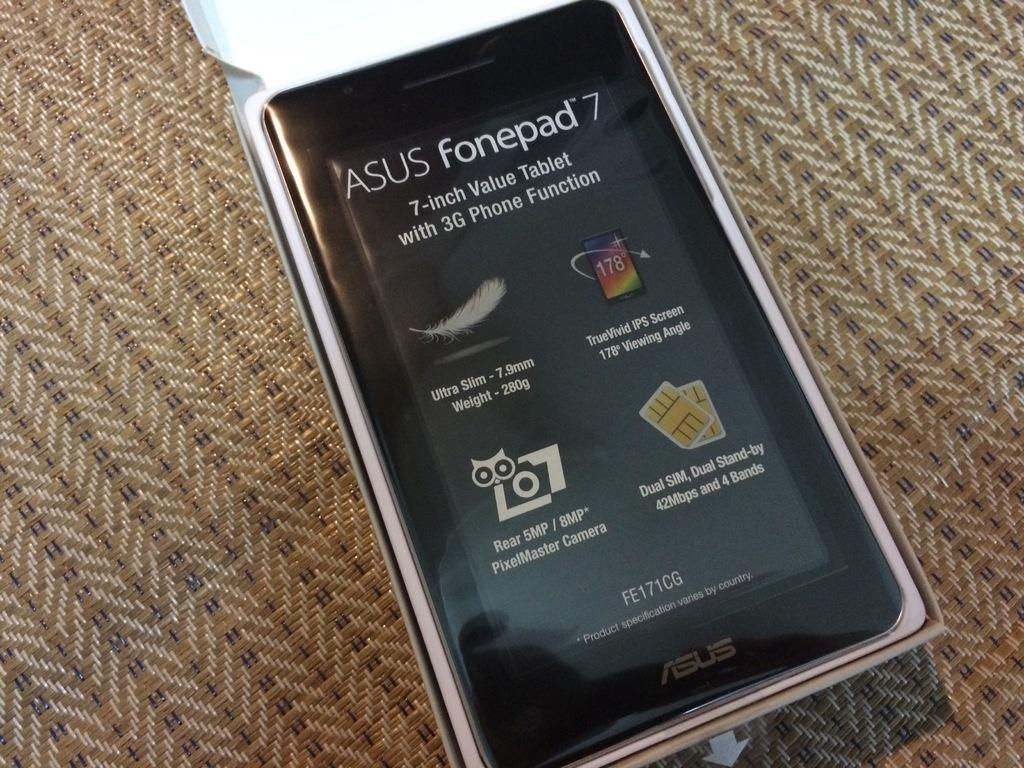<image>
Offer a succinct explanation of the picture presented. An Asus fonepad 7 device placed on a woven fabric. 